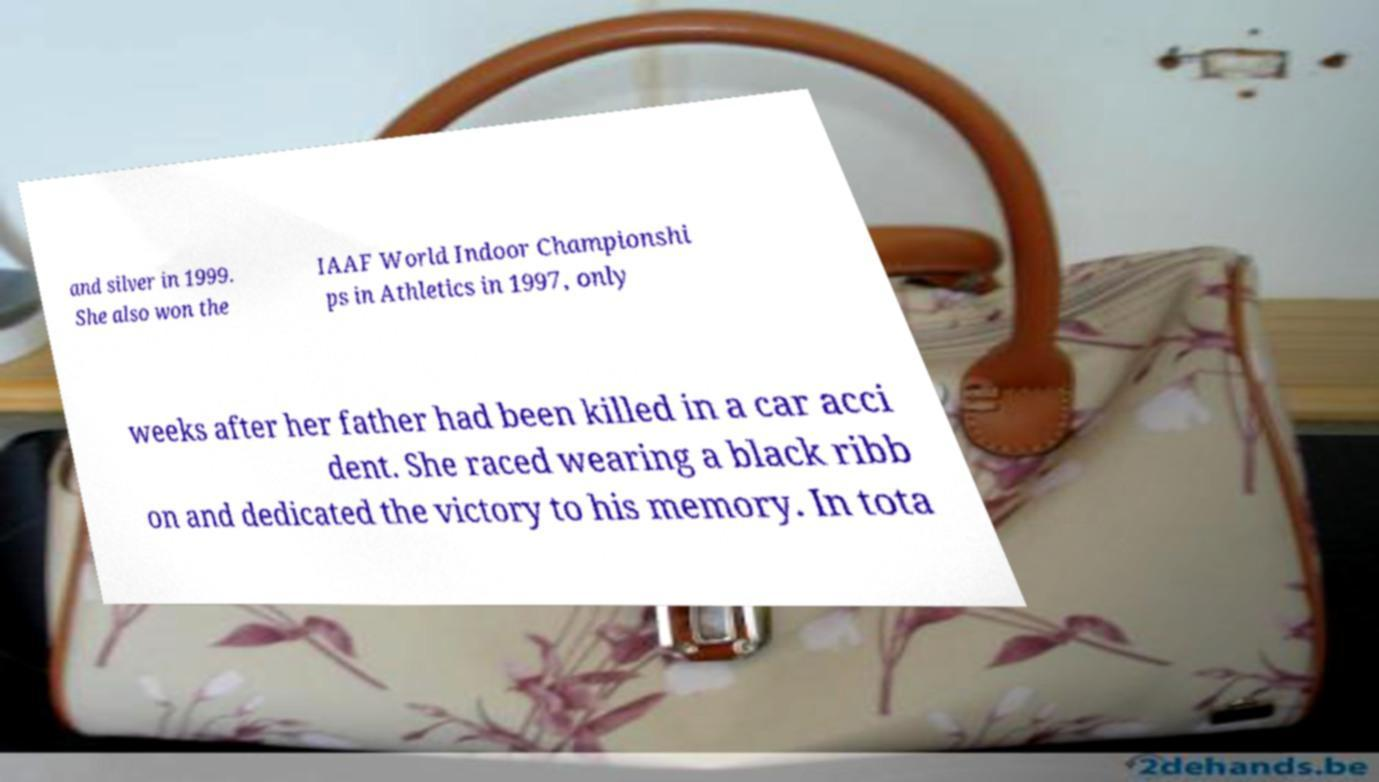Can you read and provide the text displayed in the image?This photo seems to have some interesting text. Can you extract and type it out for me? and silver in 1999. She also won the IAAF World Indoor Championshi ps in Athletics in 1997, only weeks after her father had been killed in a car acci dent. She raced wearing a black ribb on and dedicated the victory to his memory. In tota 